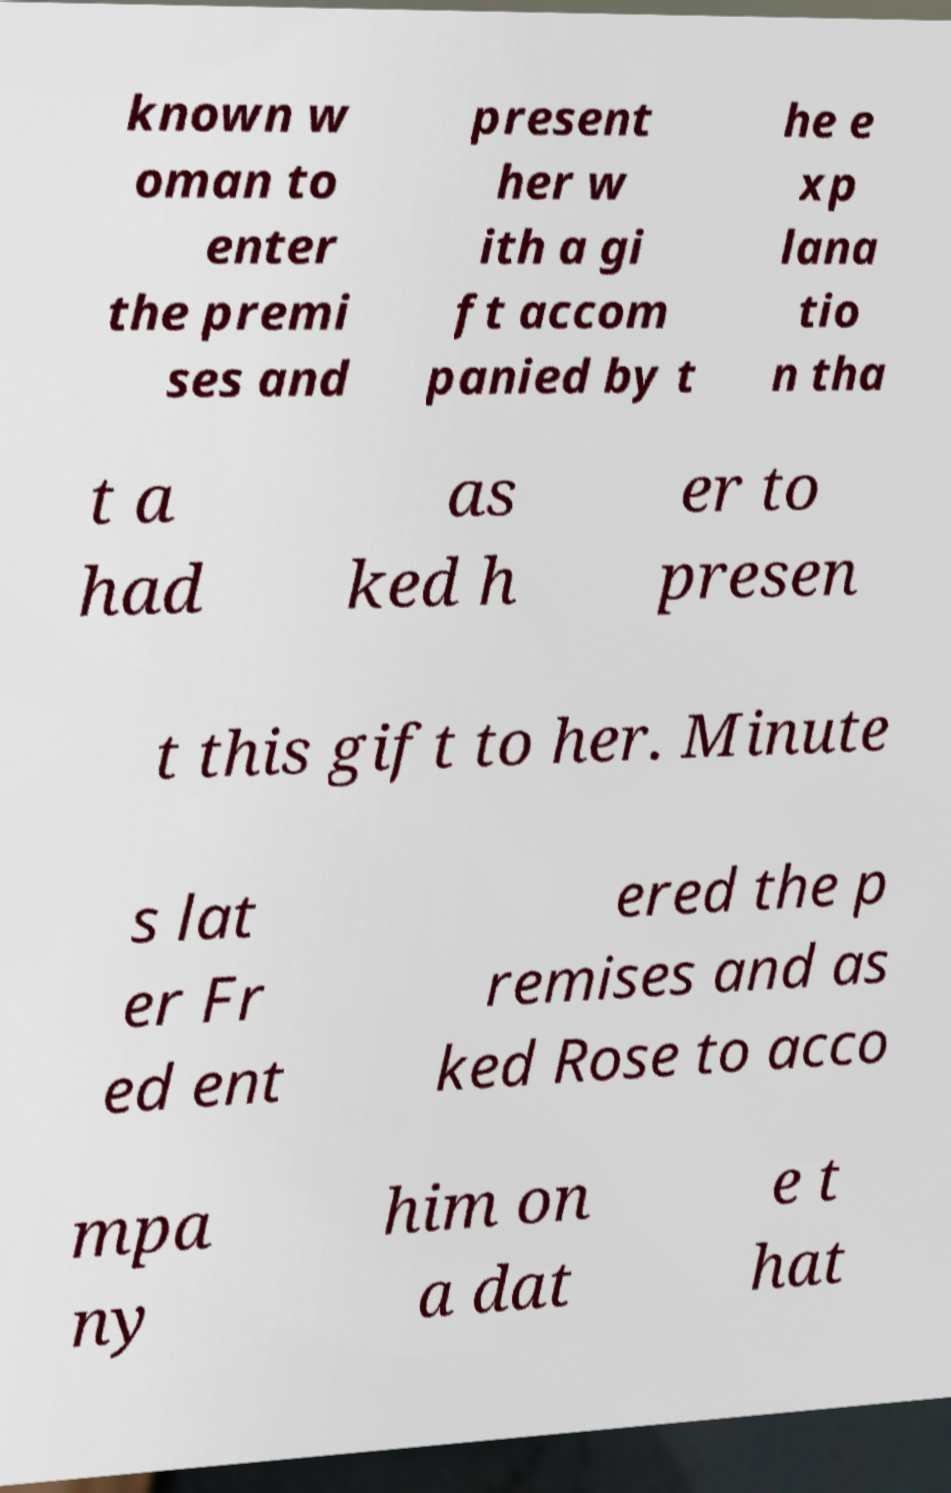Can you accurately transcribe the text from the provided image for me? known w oman to enter the premi ses and present her w ith a gi ft accom panied by t he e xp lana tio n tha t a had as ked h er to presen t this gift to her. Minute s lat er Fr ed ent ered the p remises and as ked Rose to acco mpa ny him on a dat e t hat 